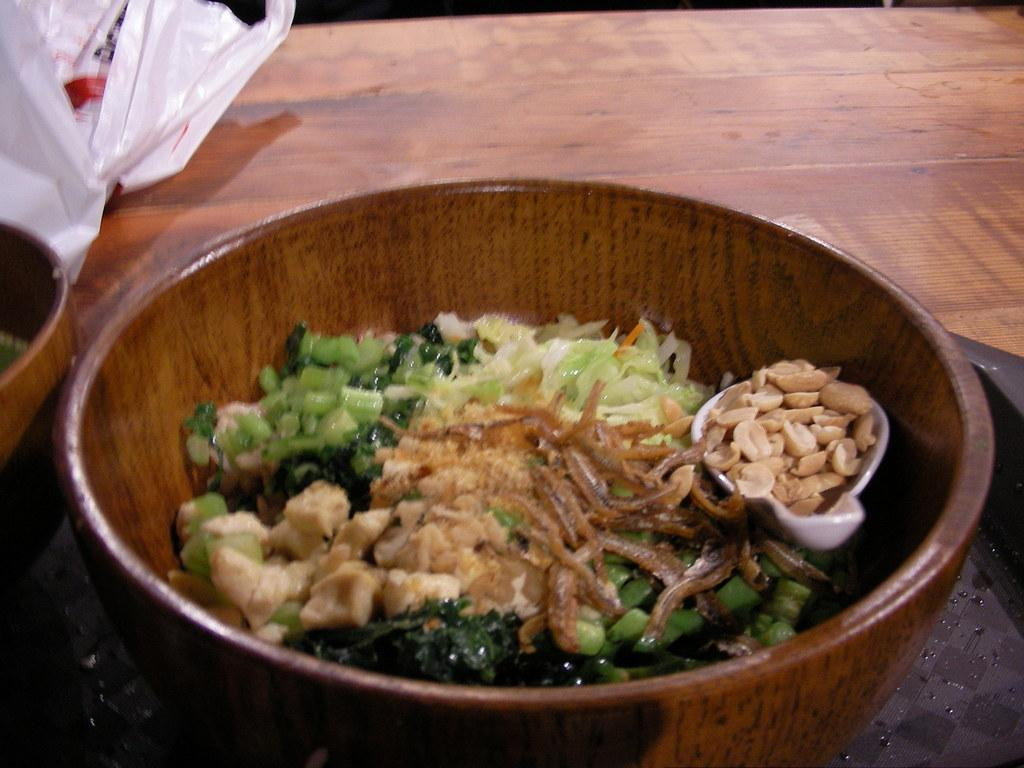What objects are on the table in the image? There are bowls, a tray, and a cover on the table in the image. What might the bowls be used for? The bowls might be used for serving food or holding various items. What is the purpose of the tray on the table? The tray might be used for holding or transporting multiple items at once. What is the function of the cover on the table? The cover might be used to protect the items on the table from dust, spills, or other contaminants. What type of harmony can be heard in the background of the image? There is no audible sound or harmony present in the image, as it is a still image of objects on a table. 